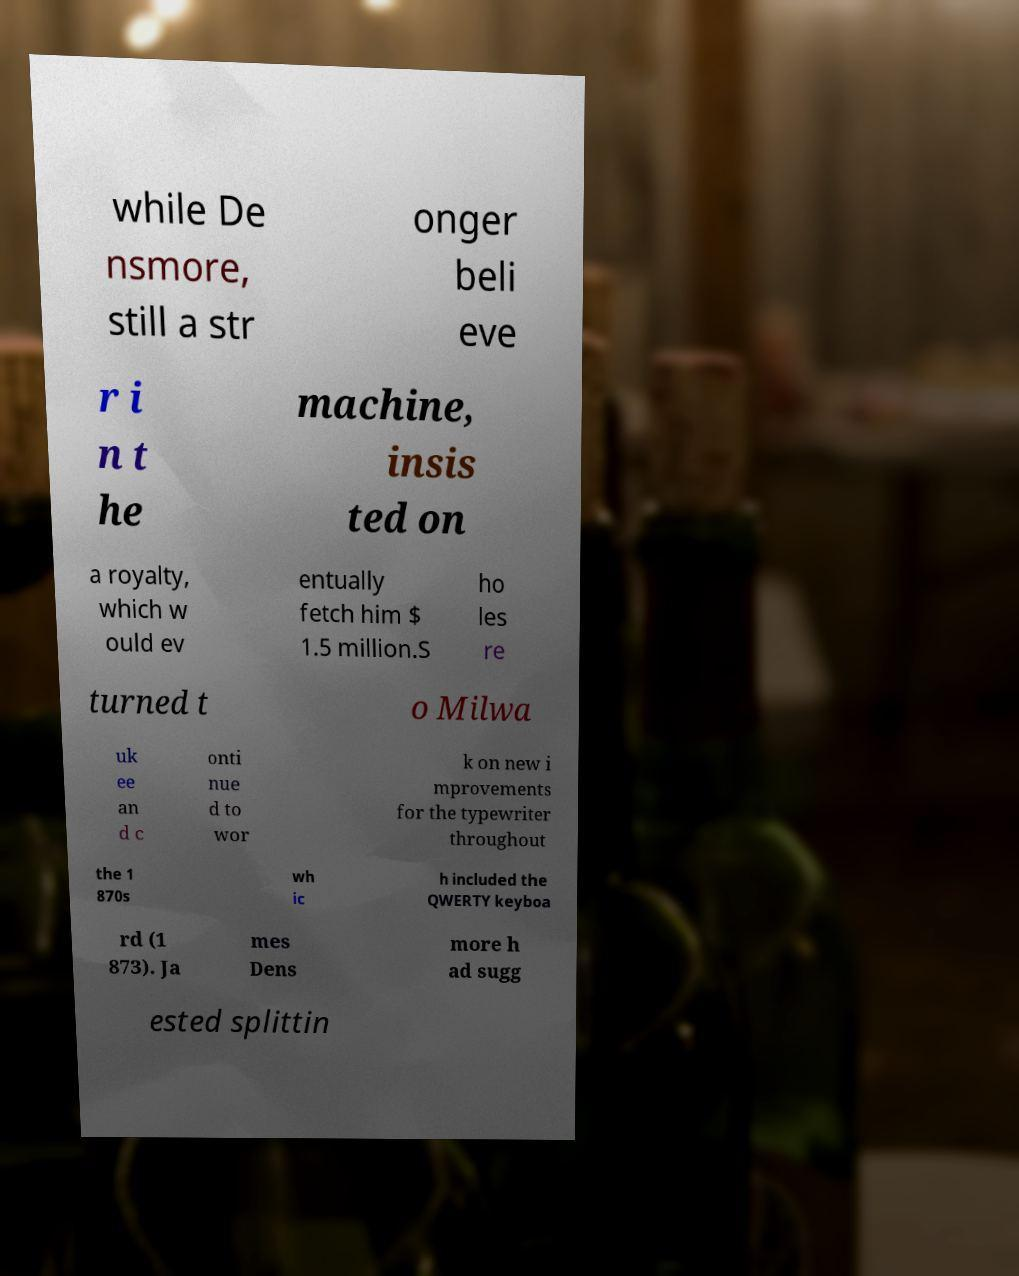Please read and relay the text visible in this image. What does it say? while De nsmore, still a str onger beli eve r i n t he machine, insis ted on a royalty, which w ould ev entually fetch him $ 1.5 million.S ho les re turned t o Milwa uk ee an d c onti nue d to wor k on new i mprovements for the typewriter throughout the 1 870s wh ic h included the QWERTY keyboa rd (1 873). Ja mes Dens more h ad sugg ested splittin 